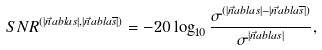<formula> <loc_0><loc_0><loc_500><loc_500>S N R ^ { ( | \vec { n } a b l a s | , | \vec { n } a b l a \overline { s } | ) } = - 2 0 \log _ { 1 0 } \frac { \sigma ^ { ( | \vec { n } a b l a s | - | \vec { n } a b l a \overline { s } | ) } } { \sigma ^ { | \vec { n } a b l a s | } } ,</formula> 